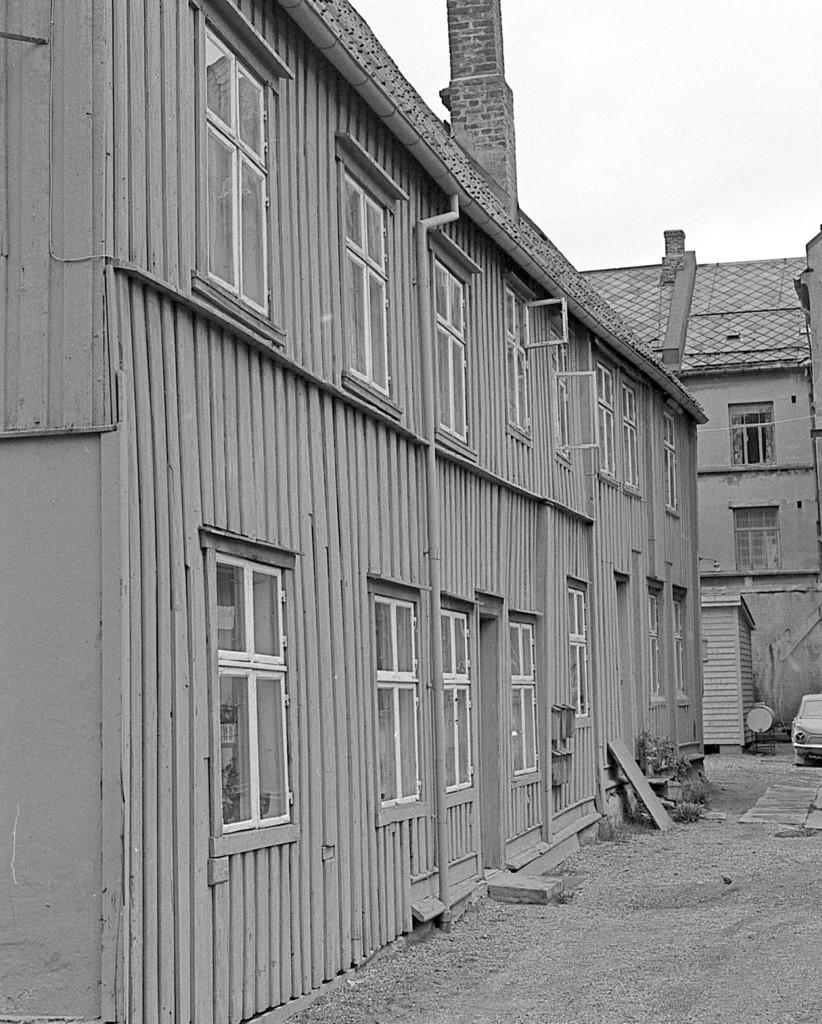How would you summarize this image in a sentence or two? In this image there is a building with windows, and in the background there is another building, car, shed ,skye. 